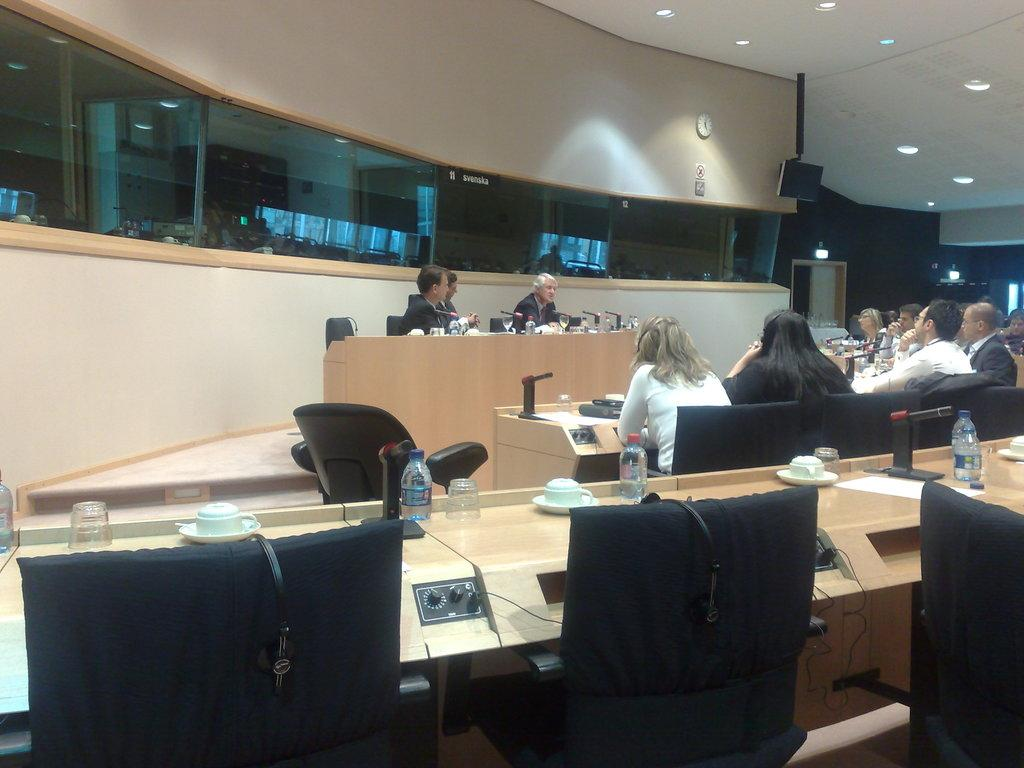What are the people in the image doing? The people in the image are sitting on chairs. What is present in the image besides the people? There is a table in the image. What can be seen on the table? There is a water bottle, a glass, a cup, and a soccer ball on the table. Is there steam coming out of the water bottle in the image? No, there is no steam coming out of the water bottle in the image. 